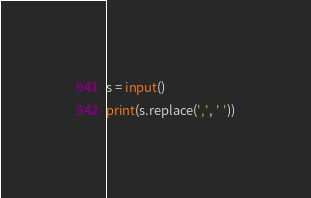<code> <loc_0><loc_0><loc_500><loc_500><_Python_>s = input()
print(s.replace(',', ' '))</code> 